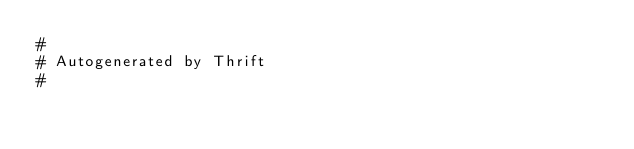<code> <loc_0><loc_0><loc_500><loc_500><_Cython_>#
# Autogenerated by Thrift
#</code> 